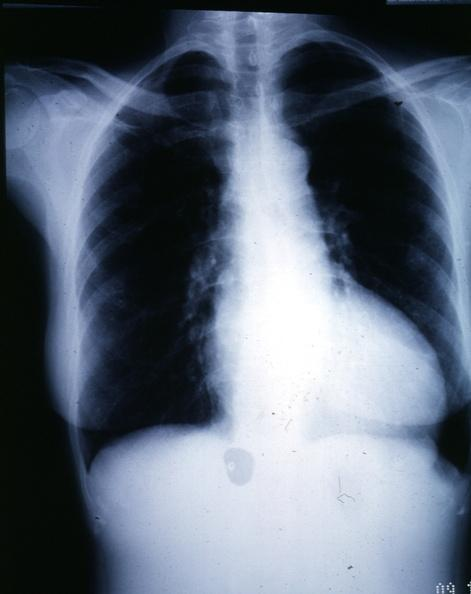what is present?
Answer the question using a single word or phrase. Cardiovascular 